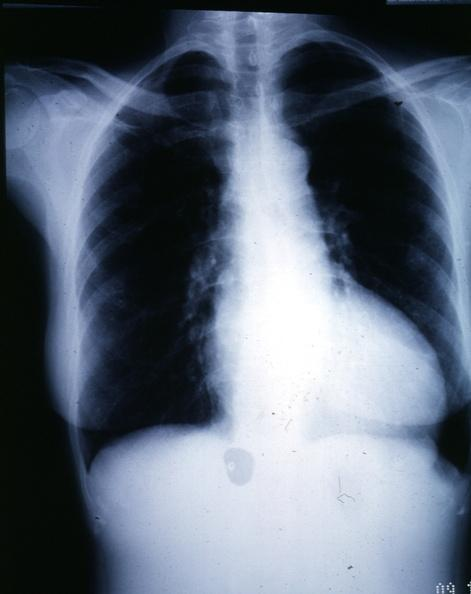what is present?
Answer the question using a single word or phrase. Cardiovascular 